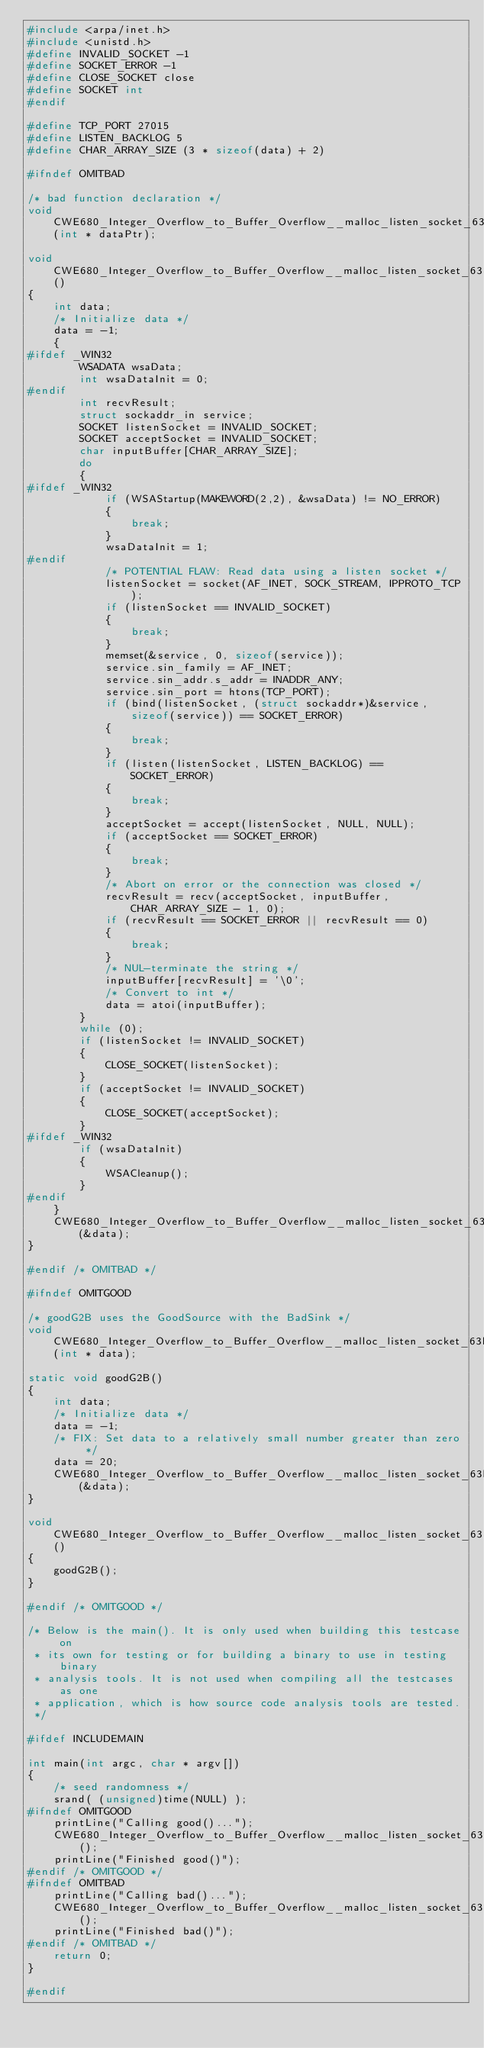Convert code to text. <code><loc_0><loc_0><loc_500><loc_500><_C_>#include <arpa/inet.h>
#include <unistd.h>
#define INVALID_SOCKET -1
#define SOCKET_ERROR -1
#define CLOSE_SOCKET close
#define SOCKET int
#endif

#define TCP_PORT 27015
#define LISTEN_BACKLOG 5
#define CHAR_ARRAY_SIZE (3 * sizeof(data) + 2)

#ifndef OMITBAD

/* bad function declaration */
void CWE680_Integer_Overflow_to_Buffer_Overflow__malloc_listen_socket_63b_badSink(int * dataPtr);

void CWE680_Integer_Overflow_to_Buffer_Overflow__malloc_listen_socket_63_bad()
{
    int data;
    /* Initialize data */
    data = -1;
    {
#ifdef _WIN32
        WSADATA wsaData;
        int wsaDataInit = 0;
#endif
        int recvResult;
        struct sockaddr_in service;
        SOCKET listenSocket = INVALID_SOCKET;
        SOCKET acceptSocket = INVALID_SOCKET;
        char inputBuffer[CHAR_ARRAY_SIZE];
        do
        {
#ifdef _WIN32
            if (WSAStartup(MAKEWORD(2,2), &wsaData) != NO_ERROR)
            {
                break;
            }
            wsaDataInit = 1;
#endif
            /* POTENTIAL FLAW: Read data using a listen socket */
            listenSocket = socket(AF_INET, SOCK_STREAM, IPPROTO_TCP);
            if (listenSocket == INVALID_SOCKET)
            {
                break;
            }
            memset(&service, 0, sizeof(service));
            service.sin_family = AF_INET;
            service.sin_addr.s_addr = INADDR_ANY;
            service.sin_port = htons(TCP_PORT);
            if (bind(listenSocket, (struct sockaddr*)&service, sizeof(service)) == SOCKET_ERROR)
            {
                break;
            }
            if (listen(listenSocket, LISTEN_BACKLOG) == SOCKET_ERROR)
            {
                break;
            }
            acceptSocket = accept(listenSocket, NULL, NULL);
            if (acceptSocket == SOCKET_ERROR)
            {
                break;
            }
            /* Abort on error or the connection was closed */
            recvResult = recv(acceptSocket, inputBuffer, CHAR_ARRAY_SIZE - 1, 0);
            if (recvResult == SOCKET_ERROR || recvResult == 0)
            {
                break;
            }
            /* NUL-terminate the string */
            inputBuffer[recvResult] = '\0';
            /* Convert to int */
            data = atoi(inputBuffer);
        }
        while (0);
        if (listenSocket != INVALID_SOCKET)
        {
            CLOSE_SOCKET(listenSocket);
        }
        if (acceptSocket != INVALID_SOCKET)
        {
            CLOSE_SOCKET(acceptSocket);
        }
#ifdef _WIN32
        if (wsaDataInit)
        {
            WSACleanup();
        }
#endif
    }
    CWE680_Integer_Overflow_to_Buffer_Overflow__malloc_listen_socket_63b_badSink(&data);
}

#endif /* OMITBAD */

#ifndef OMITGOOD

/* goodG2B uses the GoodSource with the BadSink */
void CWE680_Integer_Overflow_to_Buffer_Overflow__malloc_listen_socket_63b_goodG2BSink(int * data);

static void goodG2B()
{
    int data;
    /* Initialize data */
    data = -1;
    /* FIX: Set data to a relatively small number greater than zero */
    data = 20;
    CWE680_Integer_Overflow_to_Buffer_Overflow__malloc_listen_socket_63b_goodG2BSink(&data);
}

void CWE680_Integer_Overflow_to_Buffer_Overflow__malloc_listen_socket_63_good()
{
    goodG2B();
}

#endif /* OMITGOOD */

/* Below is the main(). It is only used when building this testcase on
 * its own for testing or for building a binary to use in testing binary
 * analysis tools. It is not used when compiling all the testcases as one
 * application, which is how source code analysis tools are tested.
 */

#ifdef INCLUDEMAIN

int main(int argc, char * argv[])
{
    /* seed randomness */
    srand( (unsigned)time(NULL) );
#ifndef OMITGOOD
    printLine("Calling good()...");
    CWE680_Integer_Overflow_to_Buffer_Overflow__malloc_listen_socket_63_good();
    printLine("Finished good()");
#endif /* OMITGOOD */
#ifndef OMITBAD
    printLine("Calling bad()...");
    CWE680_Integer_Overflow_to_Buffer_Overflow__malloc_listen_socket_63_bad();
    printLine("Finished bad()");
#endif /* OMITBAD */
    return 0;
}

#endif
</code> 